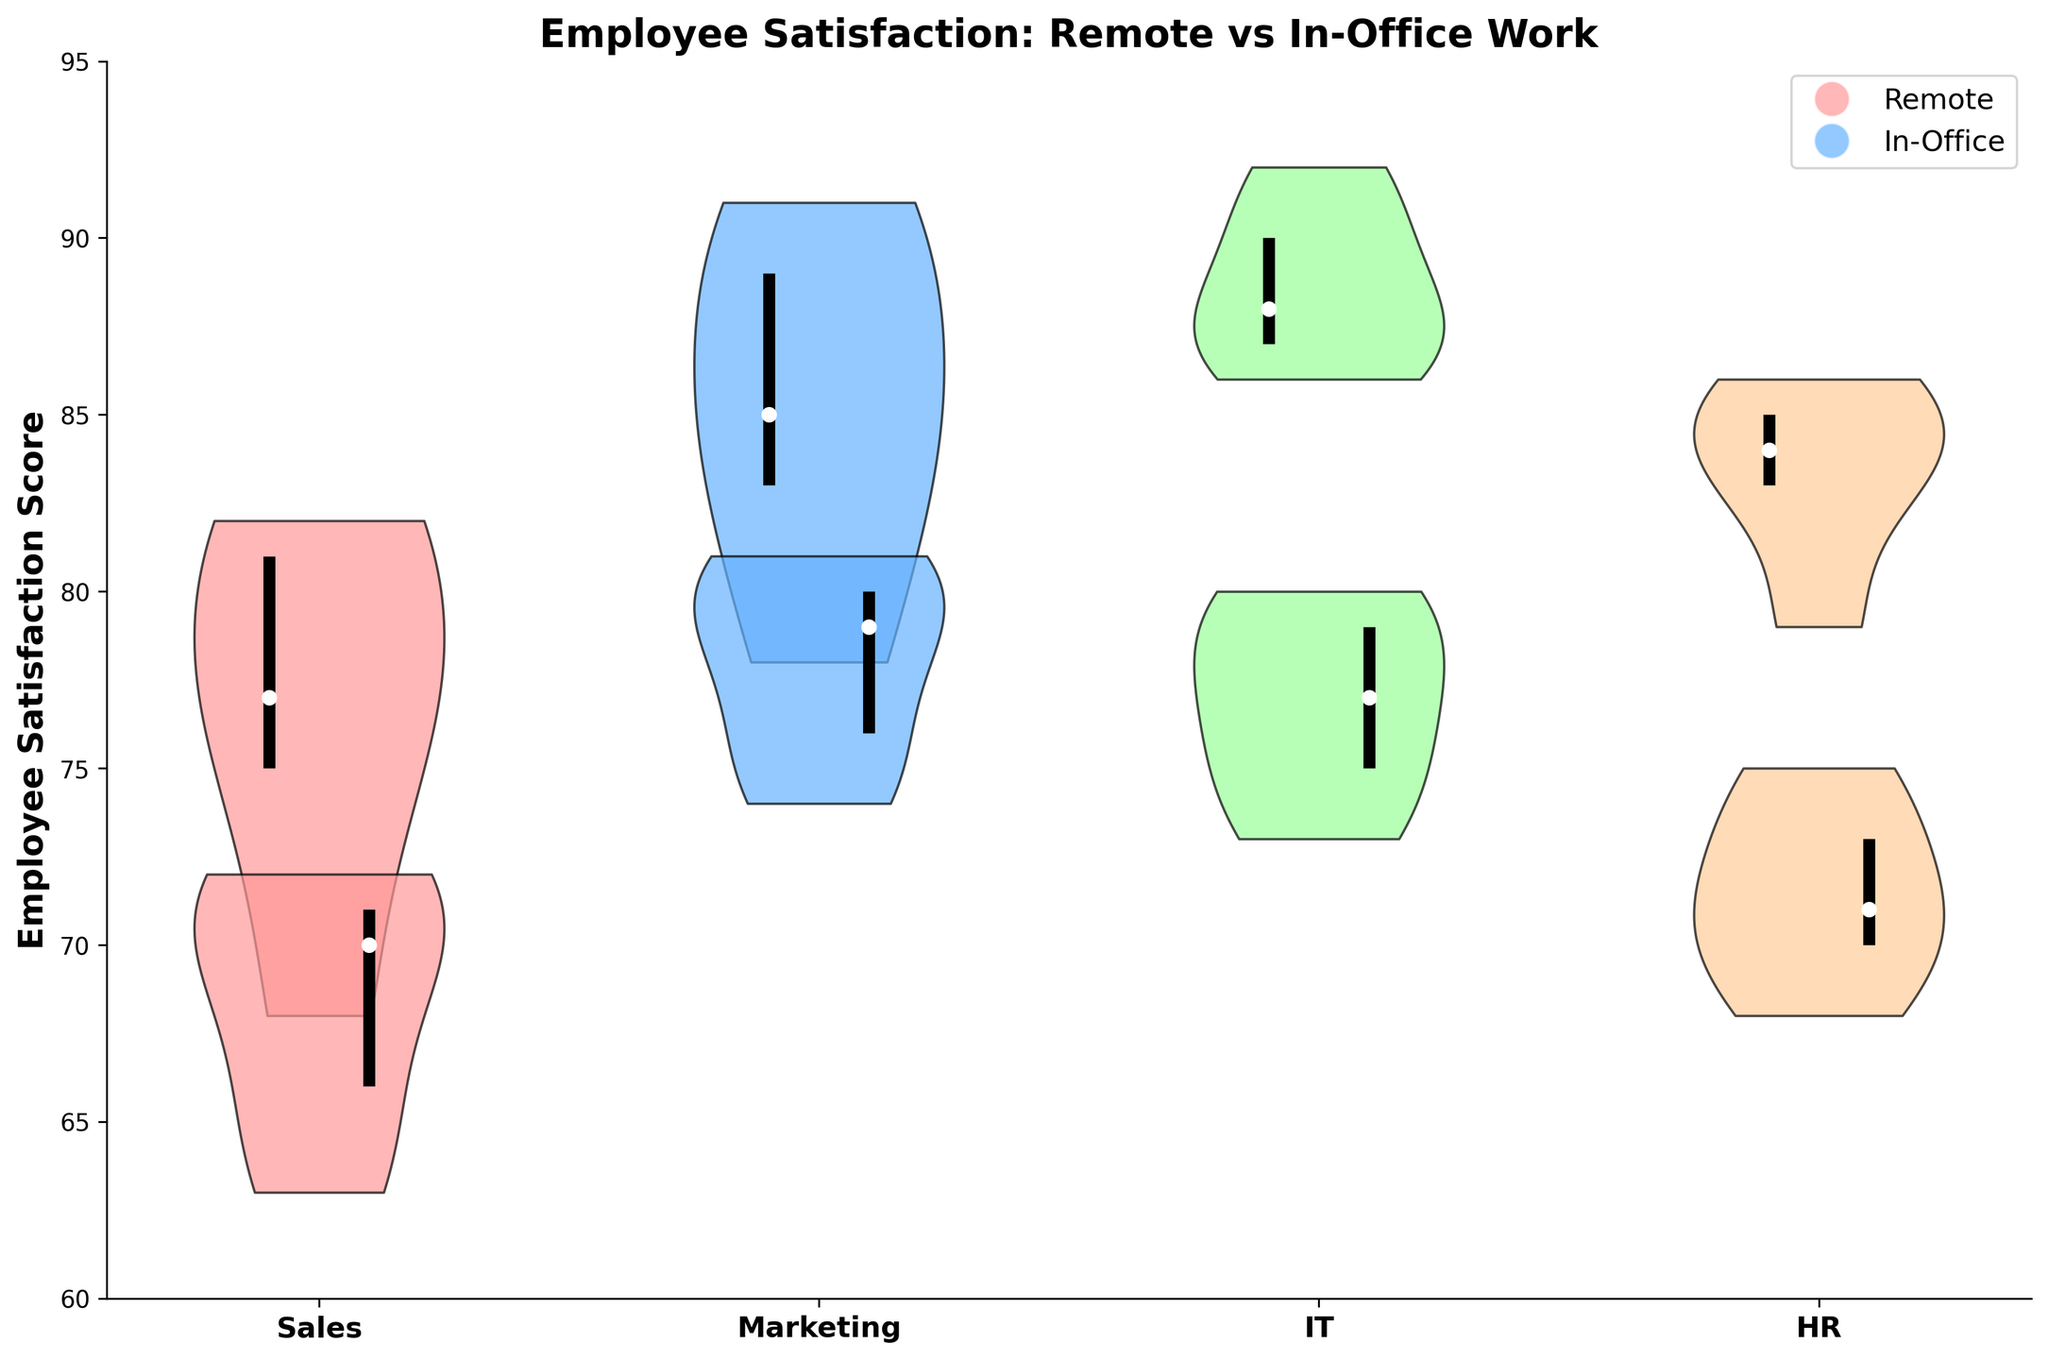What's the title of the figure? The title is located at the top of the figure and directly provides a brief about the content. It states the main topic and comparison being made.
Answer: Employee Satisfaction: Remote vs In-Office Work How are the departments represented on the x-axis? The x-axis labels correspond to different departments listed in the dataset. These labels help identify the department-specific data shown in the plot.
Answer: Sales, Marketing, IT, HR What does the y-axis represent? The y-axis tracks the Employee Satisfaction Score, used to quantify the satisfaction levels for employees in both remote and in-office work environments.
Answer: Employee Satisfaction Score Which department shows the highest median employee satisfaction score in the remote work environment? By examining the position of the white dot (representing the median) on the left side for each department, you can compare the median satisfaction scores directly.
Answer: IT In the Sales department, which work environment has a higher median employee satisfaction score? For the Sales department, compare the position of the white dots on both the remote (left) and in-office (right) work environment sides. The higher position indicates a higher median score.
Answer: Remote How do the quartiles of the remote and in-office employee satisfaction scores in the HR department compare? Quartiles can be observed through the vertical lines. Comparing their positions shows their ranges. For HR, the remote quartiles and in-office quartiles do not overlap, indicating a higher satisfaction in remote conditions.
Answer: Remote quartiles are higher Which department has the narrowest spread in employee satisfaction scores for the in-office work environment? The spread can be visually assessed by the width of the violin plot. The narrower width indicates less variability in satisfaction scores.
Answer: HR Are there any departments where the median satisfaction scores for remote and in-office work environments are equal? By comparing the position of the median markers (white dots) across all departments, you can determine if any are aligned at the same level.
Answer: No What's the range of employee satisfaction scores for the IT department's remote work environment? The range is determined by the bottom and top edges of the violin plot for the IT remote work environment, covering from the lowest to highest values.
Answer: 86 to 92 